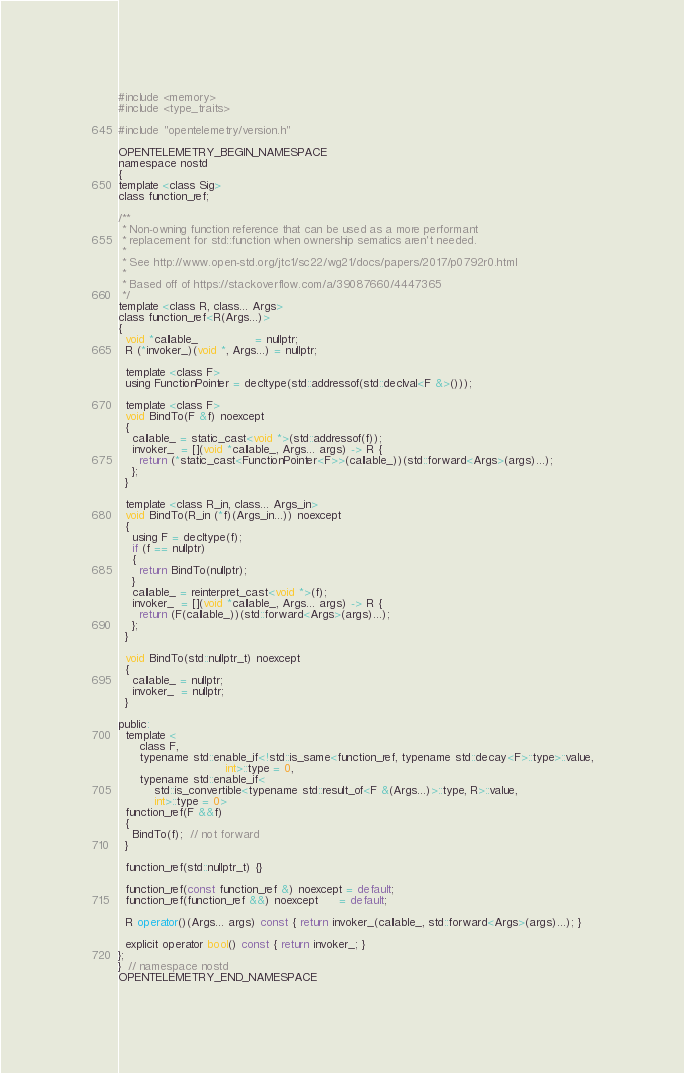Convert code to text. <code><loc_0><loc_0><loc_500><loc_500><_C_>#include <memory>
#include <type_traits>

#include "opentelemetry/version.h"

OPENTELEMETRY_BEGIN_NAMESPACE
namespace nostd
{
template <class Sig>
class function_ref;

/**
 * Non-owning function reference that can be used as a more performant
 * replacement for std::function when ownership sematics aren't needed.
 *
 * See http://www.open-std.org/jtc1/sc22/wg21/docs/papers/2017/p0792r0.html
 *
 * Based off of https://stackoverflow.com/a/39087660/4447365
 */
template <class R, class... Args>
class function_ref<R(Args...)>
{
  void *callable_                = nullptr;
  R (*invoker_)(void *, Args...) = nullptr;

  template <class F>
  using FunctionPointer = decltype(std::addressof(std::declval<F &>()));

  template <class F>
  void BindTo(F &f) noexcept
  {
    callable_ = static_cast<void *>(std::addressof(f));
    invoker_  = [](void *callable_, Args... args) -> R {
      return (*static_cast<FunctionPointer<F>>(callable_))(std::forward<Args>(args)...);
    };
  }

  template <class R_in, class... Args_in>
  void BindTo(R_in (*f)(Args_in...)) noexcept
  {
    using F = decltype(f);
    if (f == nullptr)
    {
      return BindTo(nullptr);
    }
    callable_ = reinterpret_cast<void *>(f);
    invoker_  = [](void *callable_, Args... args) -> R {
      return (F(callable_))(std::forward<Args>(args)...);
    };
  }

  void BindTo(std::nullptr_t) noexcept
  {
    callable_ = nullptr;
    invoker_  = nullptr;
  }

public:
  template <
      class F,
      typename std::enable_if<!std::is_same<function_ref, typename std::decay<F>::type>::value,
                              int>::type = 0,
      typename std::enable_if<
          std::is_convertible<typename std::result_of<F &(Args...)>::type, R>::value,
          int>::type = 0>
  function_ref(F &&f)
  {
    BindTo(f);  // not forward
  }

  function_ref(std::nullptr_t) {}

  function_ref(const function_ref &) noexcept = default;
  function_ref(function_ref &&) noexcept      = default;

  R operator()(Args... args) const { return invoker_(callable_, std::forward<Args>(args)...); }

  explicit operator bool() const { return invoker_; }
};
}  // namespace nostd
OPENTELEMETRY_END_NAMESPACE
</code> 